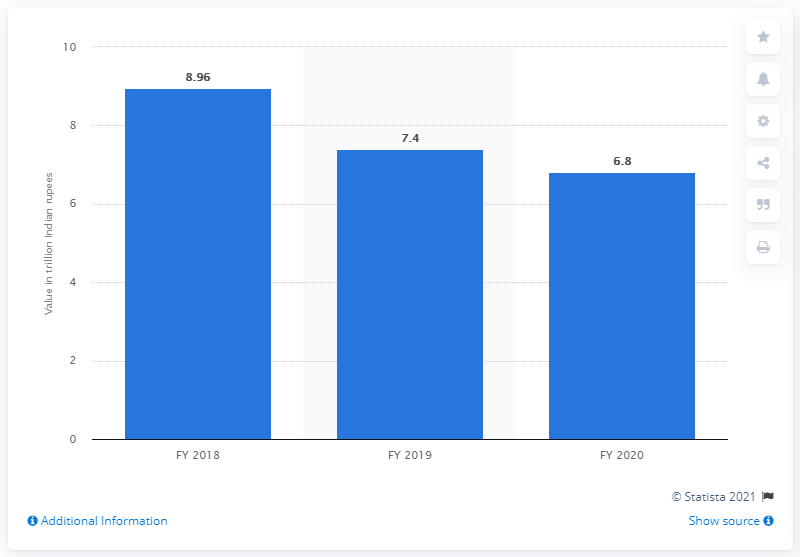List a handful of essential elements in this visual. Indian public sector banks collectively owed 6.8 trillion Indian rupees in non-performing assets in the fiscal year 2020. 